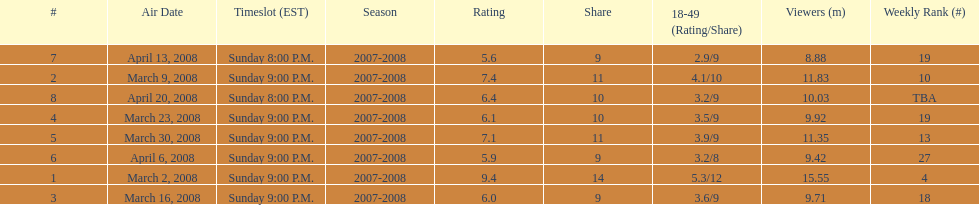How many shows had more than 10 million viewers? 4. 